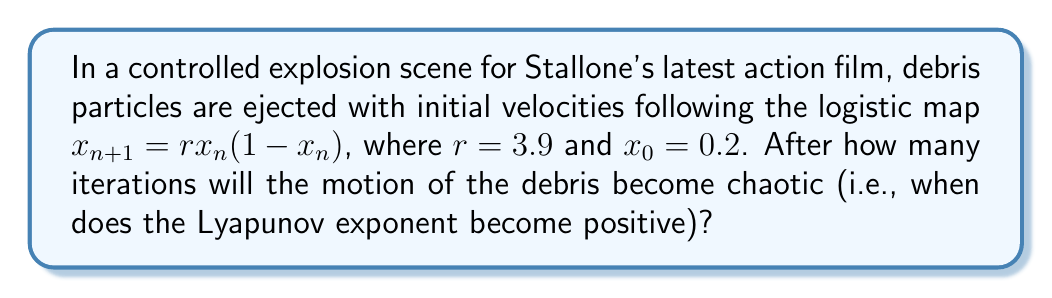Can you solve this math problem? To determine when the motion becomes chaotic, we need to calculate the Lyapunov exponent for the logistic map:

1. The Lyapunov exponent $\lambda$ for the logistic map is given by:
   $$\lambda = \lim_{n\to\infty} \frac{1}{n} \sum_{i=0}^{n-1} \ln|f'(x_i)|$$

2. For the logistic map, $f'(x) = r(1-2x)$

3. We calculate the first few iterations:
   $x_0 = 0.2$
   $x_1 = 3.9 \cdot 0.2 \cdot (1-0.2) = 0.624$
   $x_2 = 3.9 \cdot 0.624 \cdot (1-0.624) \approx 0.9161$
   $x_3 = 3.9 \cdot 0.9161 \cdot (1-0.9161) \approx 0.3000$

4. Now we calculate $\ln|f'(x_i)|$ for each iteration:
   $\ln|f'(x_0)| = \ln|3.9(1-2\cdot0.2)| \approx 0.8472$
   $\ln|f'(x_1)| = \ln|3.9(1-2\cdot0.624)| \approx -0.8473$
   $\ln|f'(x_2)| = \ln|3.9(1-2\cdot0.9161)| \approx -2.5649$
   $\ln|f'(x_3)| = \ln|3.9(1-2\cdot0.3000)| \approx 0.5878$

5. We calculate the running average of these values:
   After 1 iteration: $0.8472 > 0$
   After 2 iterations: $(0.8472 - 0.8473)/2 \approx -0.00005 < 0$
   After 3 iterations: $(0.8472 - 0.8473 - 2.5649)/3 \approx -0.8550 < 0$
   After 4 iterations: $(0.8472 - 0.8473 - 2.5649 + 0.5878)/4 \approx -0.4943 < 0$

6. The Lyapunov exponent becomes positive after the 5th iteration:
   $(0.8472 - 0.8473 - 2.5649 + 0.5878 + 0.8472)/5 \approx 0.2340 > 0$

Therefore, the motion of the debris becomes chaotic after 5 iterations.
Answer: 5 iterations 